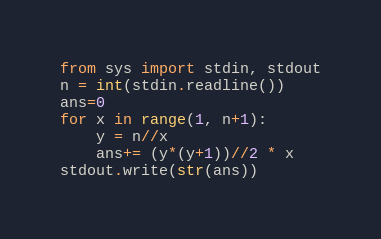<code> <loc_0><loc_0><loc_500><loc_500><_Python_>from sys import stdin, stdout
n = int(stdin.readline())
ans=0
for x in range(1, n+1):
    y = n//x 
    ans+= (y*(y+1))//2 * x 
stdout.write(str(ans))
</code> 